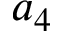Convert formula to latex. <formula><loc_0><loc_0><loc_500><loc_500>a _ { 4 }</formula> 